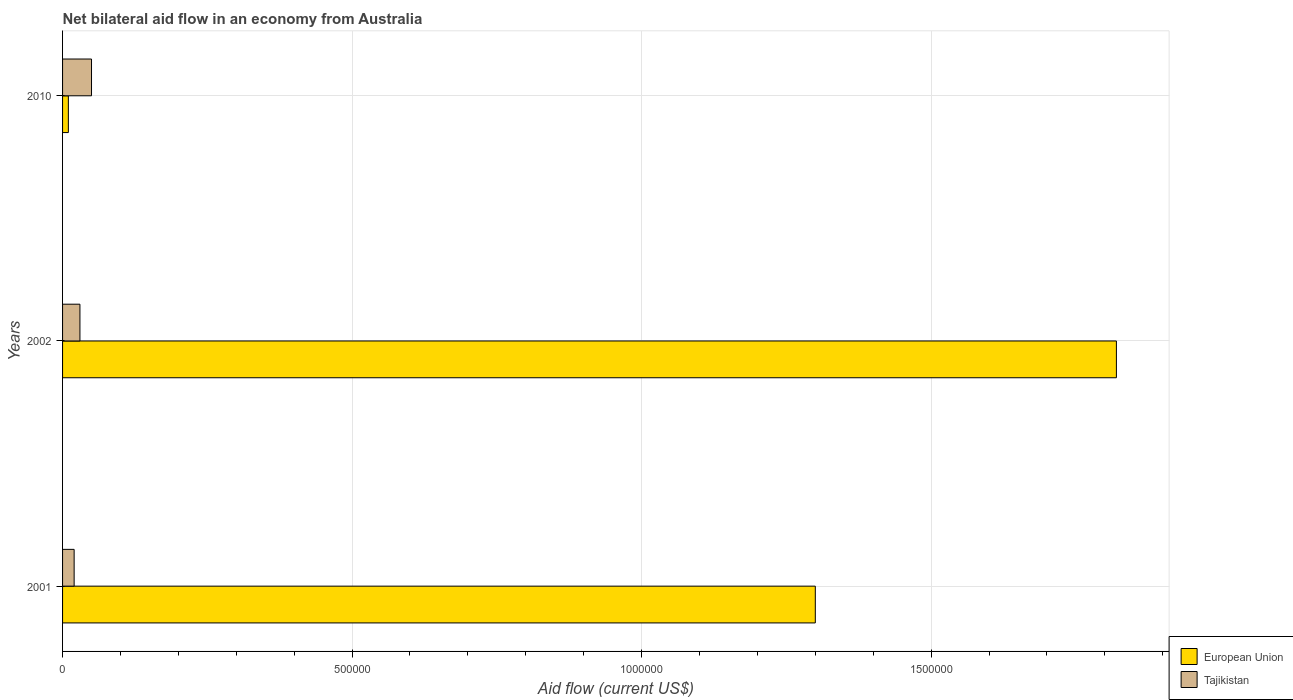How many groups of bars are there?
Give a very brief answer. 3. Are the number of bars on each tick of the Y-axis equal?
Offer a terse response. Yes. How many bars are there on the 3rd tick from the top?
Give a very brief answer. 2. How many bars are there on the 1st tick from the bottom?
Your answer should be very brief. 2. In how many cases, is the number of bars for a given year not equal to the number of legend labels?
Ensure brevity in your answer.  0. What is the net bilateral aid flow in European Union in 2002?
Make the answer very short. 1.82e+06. Across all years, what is the maximum net bilateral aid flow in Tajikistan?
Your answer should be compact. 5.00e+04. In which year was the net bilateral aid flow in Tajikistan maximum?
Offer a terse response. 2010. In which year was the net bilateral aid flow in Tajikistan minimum?
Keep it short and to the point. 2001. What is the total net bilateral aid flow in Tajikistan in the graph?
Your answer should be very brief. 1.00e+05. What is the difference between the net bilateral aid flow in Tajikistan in 2010 and the net bilateral aid flow in European Union in 2001?
Provide a short and direct response. -1.25e+06. What is the average net bilateral aid flow in Tajikistan per year?
Provide a short and direct response. 3.33e+04. In how many years, is the net bilateral aid flow in Tajikistan greater than 700000 US$?
Offer a terse response. 0. What is the ratio of the net bilateral aid flow in Tajikistan in 2001 to that in 2002?
Provide a succinct answer. 0.67. Is the net bilateral aid flow in European Union in 2002 less than that in 2010?
Make the answer very short. No. What is the difference between the highest and the lowest net bilateral aid flow in Tajikistan?
Your answer should be very brief. 3.00e+04. In how many years, is the net bilateral aid flow in Tajikistan greater than the average net bilateral aid flow in Tajikistan taken over all years?
Offer a very short reply. 1. What is the difference between two consecutive major ticks on the X-axis?
Your answer should be compact. 5.00e+05. Does the graph contain any zero values?
Keep it short and to the point. No. Where does the legend appear in the graph?
Your answer should be compact. Bottom right. How many legend labels are there?
Your answer should be compact. 2. How are the legend labels stacked?
Provide a short and direct response. Vertical. What is the title of the graph?
Ensure brevity in your answer.  Net bilateral aid flow in an economy from Australia. Does "Trinidad and Tobago" appear as one of the legend labels in the graph?
Make the answer very short. No. What is the label or title of the X-axis?
Make the answer very short. Aid flow (current US$). What is the Aid flow (current US$) of European Union in 2001?
Make the answer very short. 1.30e+06. What is the Aid flow (current US$) of Tajikistan in 2001?
Your response must be concise. 2.00e+04. What is the Aid flow (current US$) in European Union in 2002?
Offer a terse response. 1.82e+06. What is the Aid flow (current US$) of Tajikistan in 2002?
Offer a terse response. 3.00e+04. What is the Aid flow (current US$) of Tajikistan in 2010?
Make the answer very short. 5.00e+04. Across all years, what is the maximum Aid flow (current US$) in European Union?
Provide a short and direct response. 1.82e+06. Across all years, what is the minimum Aid flow (current US$) in European Union?
Offer a terse response. 10000. Across all years, what is the minimum Aid flow (current US$) of Tajikistan?
Provide a short and direct response. 2.00e+04. What is the total Aid flow (current US$) of European Union in the graph?
Keep it short and to the point. 3.13e+06. What is the difference between the Aid flow (current US$) in European Union in 2001 and that in 2002?
Your response must be concise. -5.20e+05. What is the difference between the Aid flow (current US$) in Tajikistan in 2001 and that in 2002?
Make the answer very short. -10000. What is the difference between the Aid flow (current US$) of European Union in 2001 and that in 2010?
Give a very brief answer. 1.29e+06. What is the difference between the Aid flow (current US$) of European Union in 2002 and that in 2010?
Your answer should be compact. 1.81e+06. What is the difference between the Aid flow (current US$) in European Union in 2001 and the Aid flow (current US$) in Tajikistan in 2002?
Provide a short and direct response. 1.27e+06. What is the difference between the Aid flow (current US$) of European Union in 2001 and the Aid flow (current US$) of Tajikistan in 2010?
Provide a short and direct response. 1.25e+06. What is the difference between the Aid flow (current US$) of European Union in 2002 and the Aid flow (current US$) of Tajikistan in 2010?
Ensure brevity in your answer.  1.77e+06. What is the average Aid flow (current US$) in European Union per year?
Your answer should be very brief. 1.04e+06. What is the average Aid flow (current US$) of Tajikistan per year?
Make the answer very short. 3.33e+04. In the year 2001, what is the difference between the Aid flow (current US$) in European Union and Aid flow (current US$) in Tajikistan?
Provide a short and direct response. 1.28e+06. In the year 2002, what is the difference between the Aid flow (current US$) in European Union and Aid flow (current US$) in Tajikistan?
Your response must be concise. 1.79e+06. In the year 2010, what is the difference between the Aid flow (current US$) of European Union and Aid flow (current US$) of Tajikistan?
Keep it short and to the point. -4.00e+04. What is the ratio of the Aid flow (current US$) in Tajikistan in 2001 to that in 2002?
Ensure brevity in your answer.  0.67. What is the ratio of the Aid flow (current US$) in European Union in 2001 to that in 2010?
Offer a very short reply. 130. What is the ratio of the Aid flow (current US$) of European Union in 2002 to that in 2010?
Provide a short and direct response. 182. What is the difference between the highest and the second highest Aid flow (current US$) of European Union?
Provide a short and direct response. 5.20e+05. What is the difference between the highest and the second highest Aid flow (current US$) of Tajikistan?
Your response must be concise. 2.00e+04. What is the difference between the highest and the lowest Aid flow (current US$) of European Union?
Your answer should be compact. 1.81e+06. What is the difference between the highest and the lowest Aid flow (current US$) of Tajikistan?
Your answer should be very brief. 3.00e+04. 